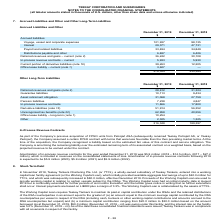According to Teekay Corporation's financial document, What was Amortization of in-process revenue contracts for the year ended December 31, 2019? According to the financial document, $5.9 million. The relevant text states: "contracts for the year ended December 31, 2019 was $5.9 million (2018 – $14.5 million, 2017 – $27.2 million), which is included in revenues on the consolidated stat contracts for the year ended Decemb..." Also, What was amortization of in-process revenue contracts for the year 2020? According to the financial document, $5.9 million. The relevant text states: "contracts for the year ended December 31, 2019 was $5.9 million (2018 – $14.5 million, 2017 – $27.2 million), which is included in revenues on the consolidated stat contracts for the year ended Decemb..." Also, What was Amortization of in-process revenue contracts for the year 2018 and 2017 respectively? The document shows two values: $14.5 million and $27.2 million. From the document: "019 was $5.9 million (2018 – $14.5 million, 2017 – $27.2 million), which is included in revenues on the consolidated statements of loss. Amortization ..." Also, can you calculate: What is the change in Deferred revenues and gains from December 31, 2019 to December 31, 2018? Based on the calculation: 28,612-31,324, the result is -2712 (in thousands). This is based on the information: "Deferred revenues and gains ( note 2 ) 28,612 31,324 Deferred revenues and gains ( note 2 ) 28,612 31,324..." The key data points involved are: 28,612, 31,324. Also, can you calculate: What is the change in Guarantee liabilities from December 31, 2019 to December 31, 2018? Based on the calculation: 10,113-9,434, the result is 679 (in thousands). This is based on the information: "Guarantee liabilities 10,113 9,434 Guarantee liabilities 10,113 9,434..." The key data points involved are: 10,113, 9,434. Also, can you calculate: What is the change in Asset retirement obligation from December 31, 2019 to December 31, 2018? Based on the calculation: 31,068-27,759, the result is 3309 (in thousands). This is based on the information: "Asset retirement obligation 31,068 27,759 Asset retirement obligation 31,068 27,759..." The key data points involved are: 27,759, 31,068. 